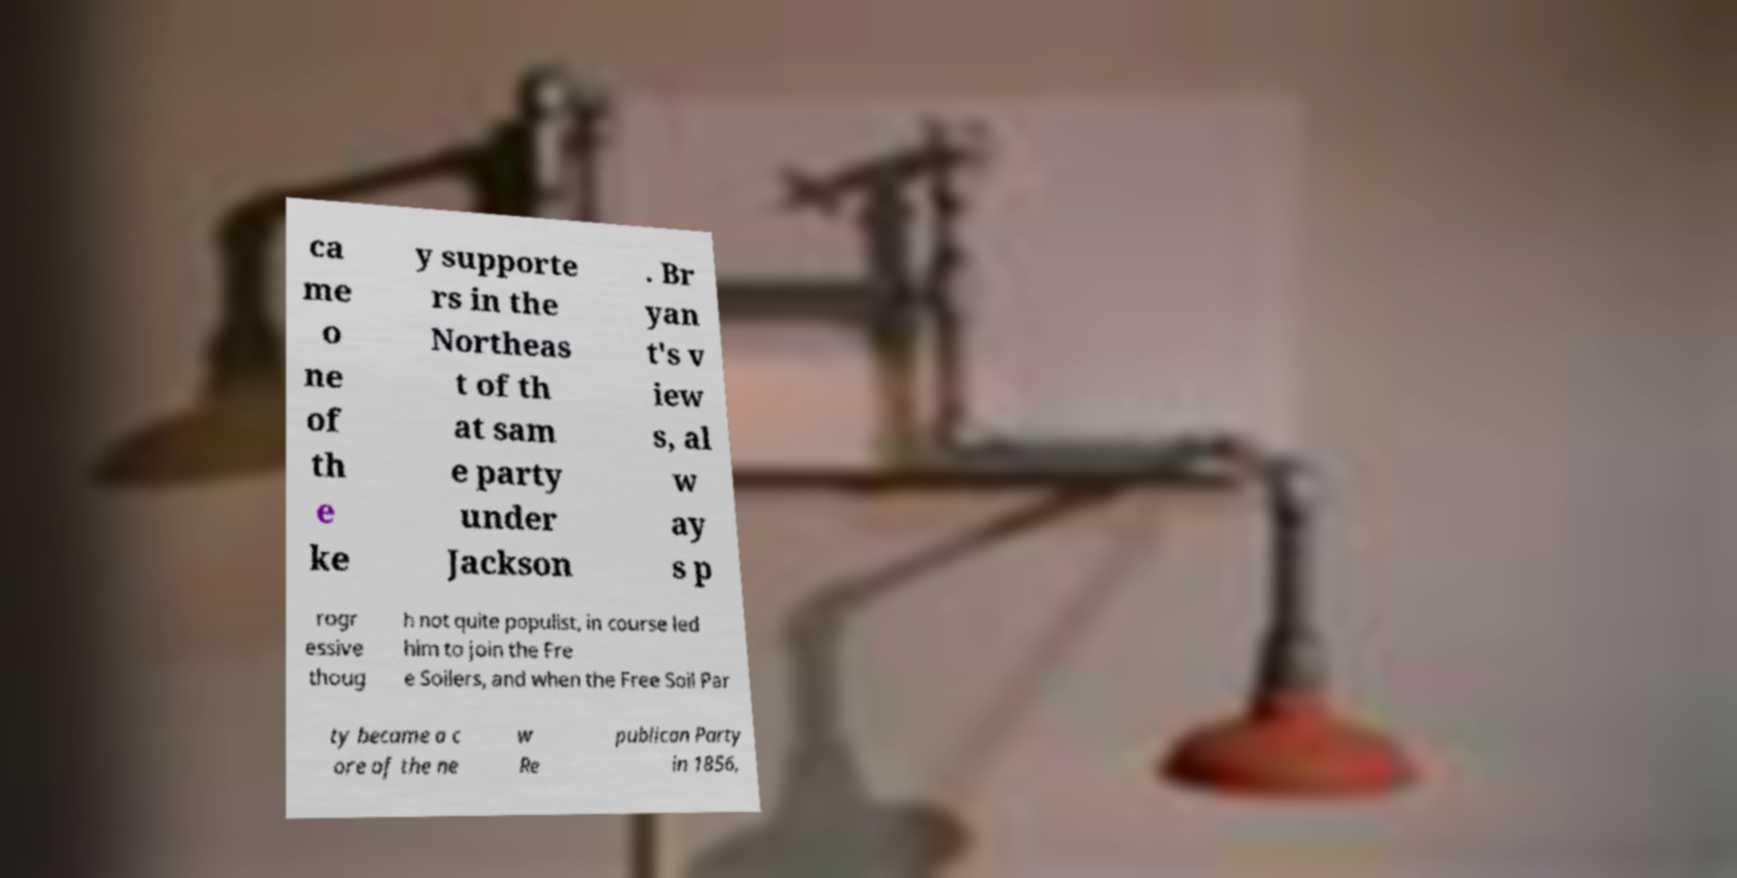For documentation purposes, I need the text within this image transcribed. Could you provide that? ca me o ne of th e ke y supporte rs in the Northeas t of th at sam e party under Jackson . Br yan t's v iew s, al w ay s p rogr essive thoug h not quite populist, in course led him to join the Fre e Soilers, and when the Free Soil Par ty became a c ore of the ne w Re publican Party in 1856, 